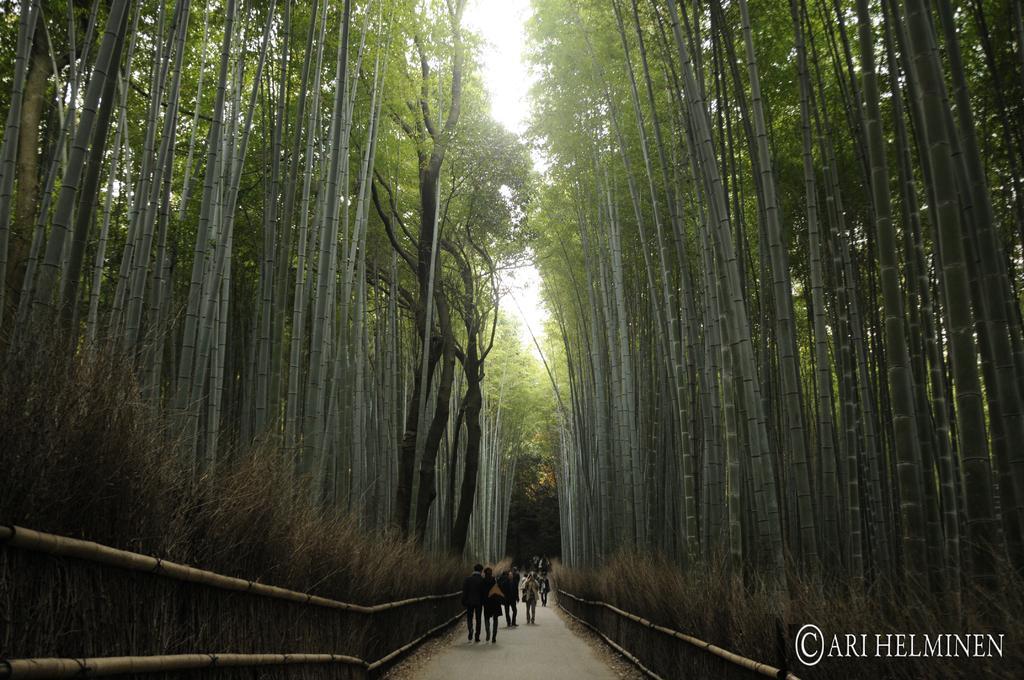How would you summarize this image in a sentence or two? In this image there is a path, on that path there are people walking, on either side of the path there is a railing and trees, on either side of the path there is a railing and trees, on the bottom right there is text. 